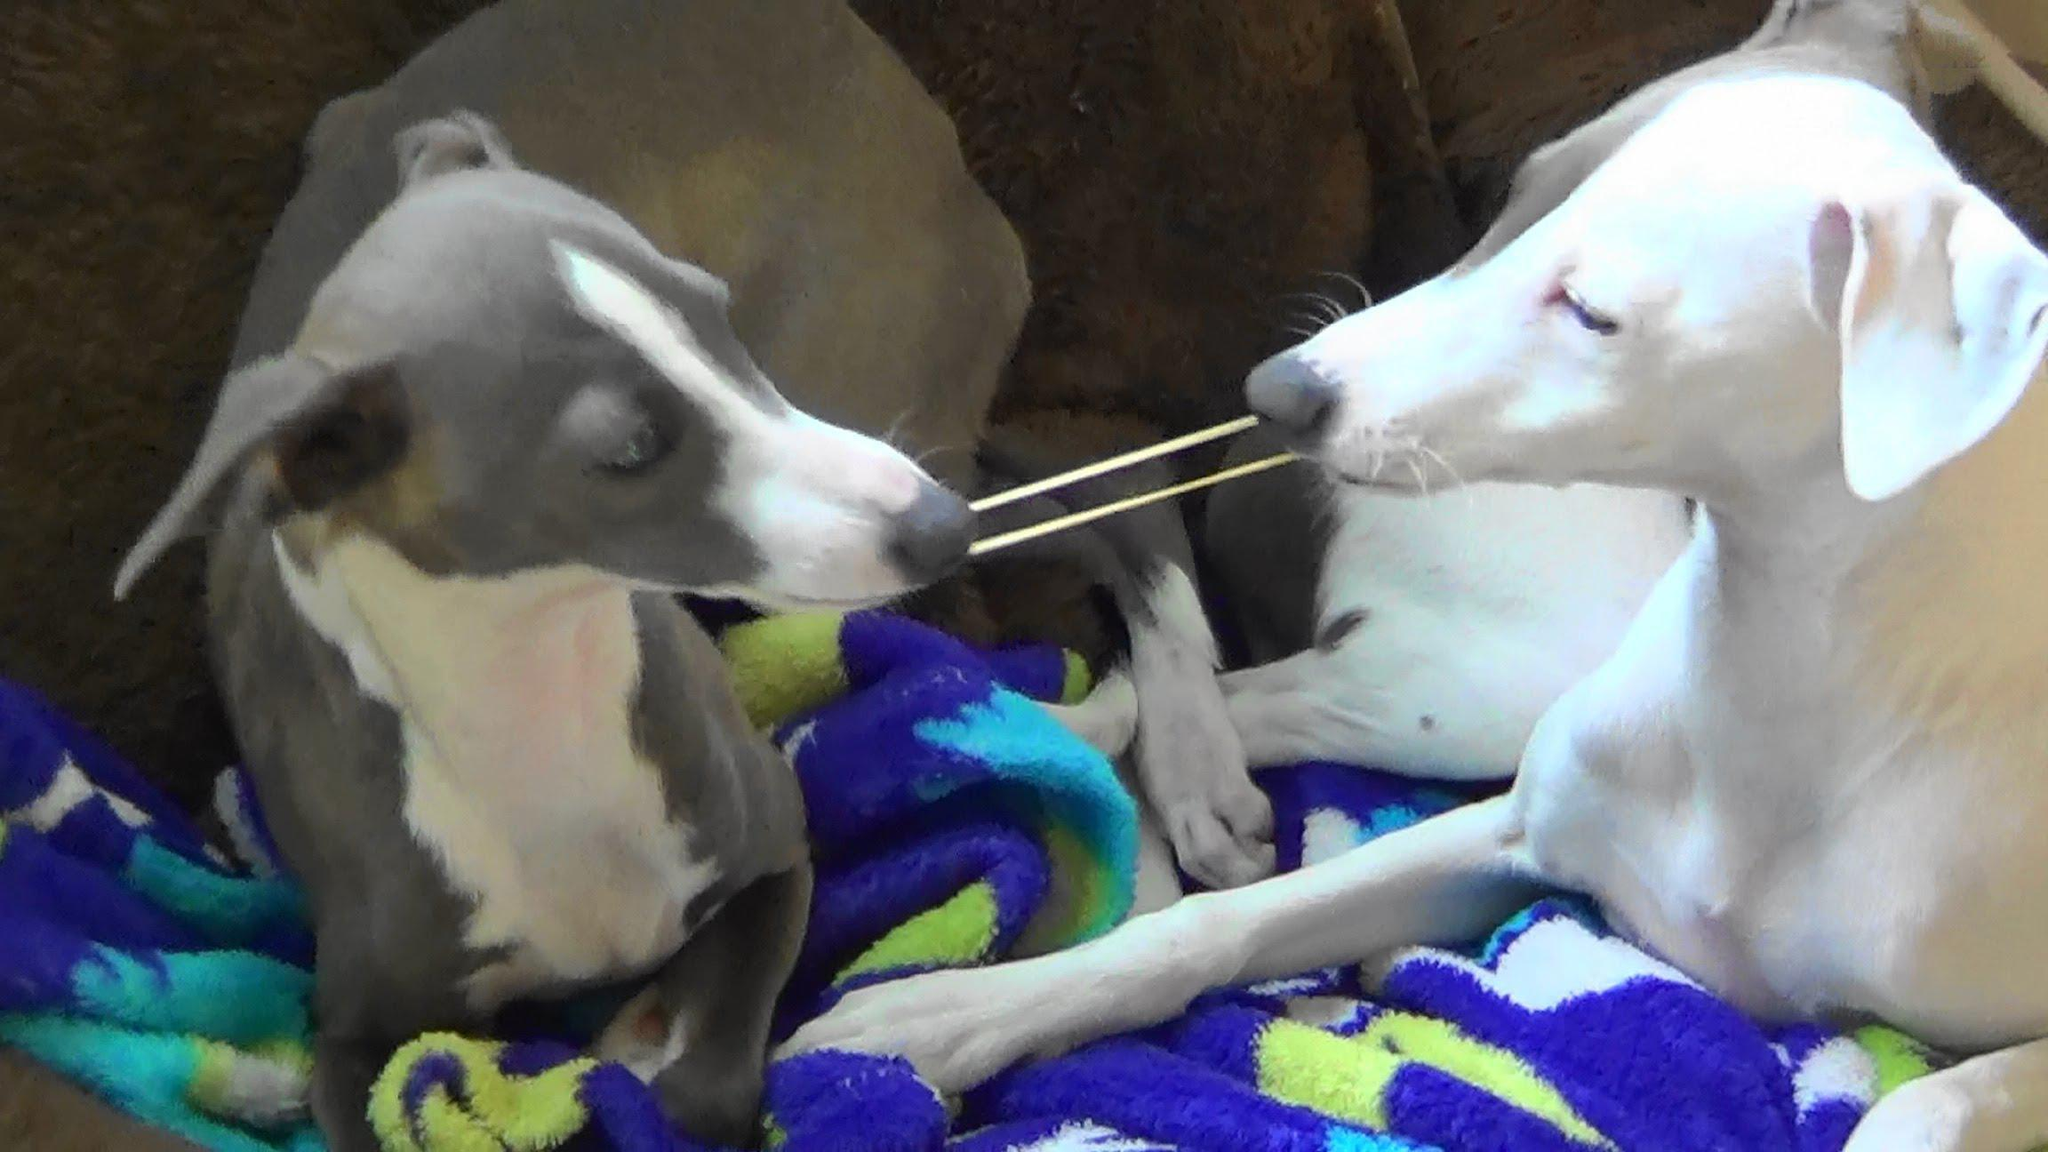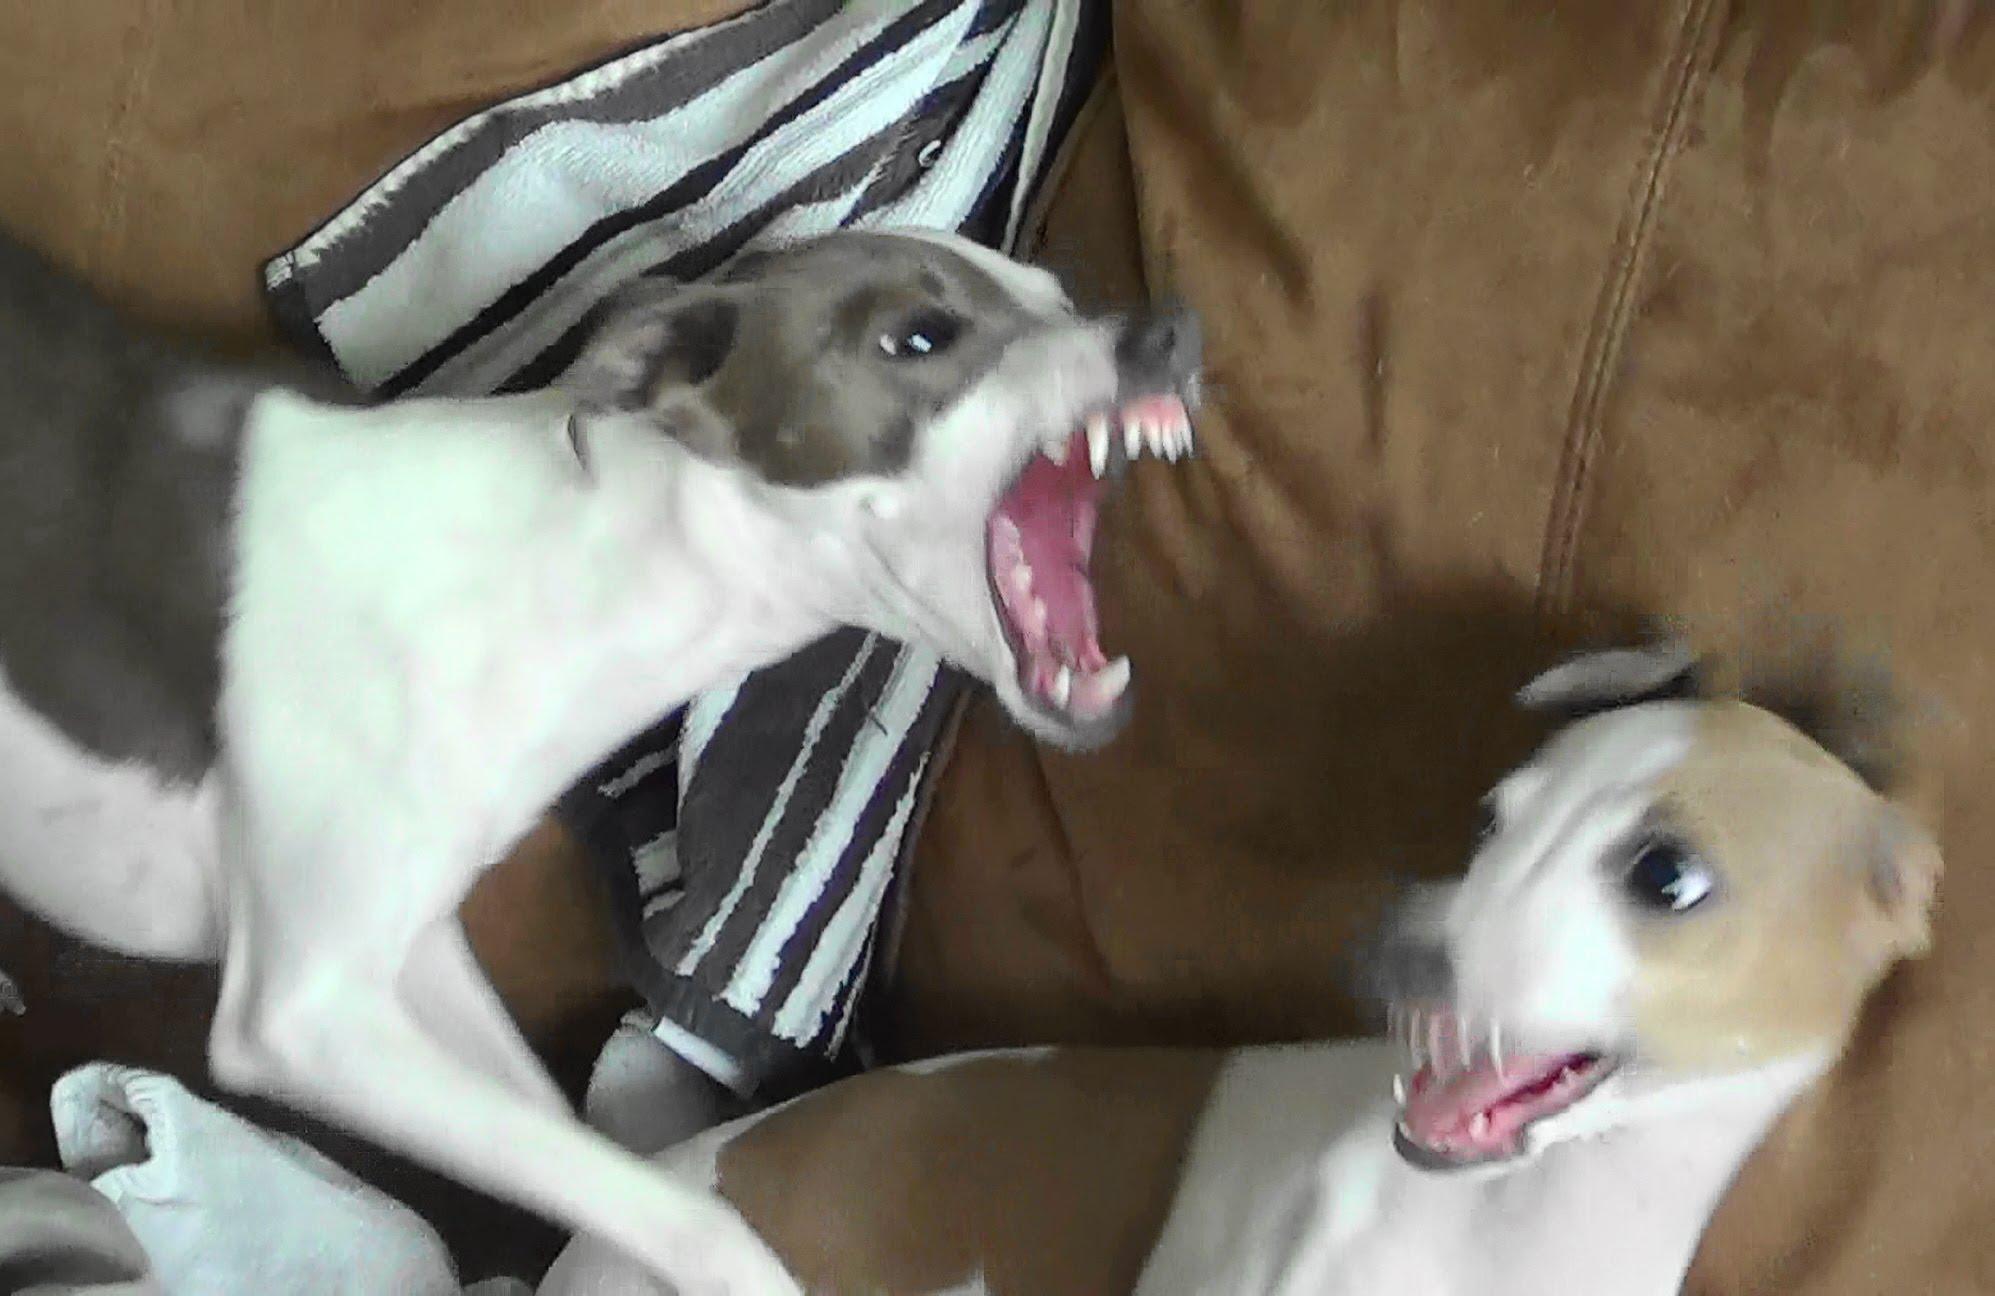The first image is the image on the left, the second image is the image on the right. Assess this claim about the two images: "a dog has it's tongue sticking out". Correct or not? Answer yes or no. No. The first image is the image on the left, the second image is the image on the right. Analyze the images presented: Is the assertion "Two dogs are near each other and 1 of them has its teeth showing." valid? Answer yes or no. Yes. 